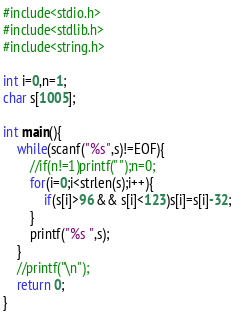Convert code to text. <code><loc_0><loc_0><loc_500><loc_500><_C_>#include<stdio.h>
#include<stdlib.h>
#include<string.h>

int i=0,n=1;
char s[1005];

int main(){
	while(scanf("%s",s)!=EOF){
		//if(n!=1)printf(" ");n=0;
		for(i=0;i<strlen(s);i++){
			if(s[i]>96 && s[i]<123)s[i]=s[i]-32;
		}
		printf("%s ",s);
	}
	//printf("\n");
	return 0;
}</code> 